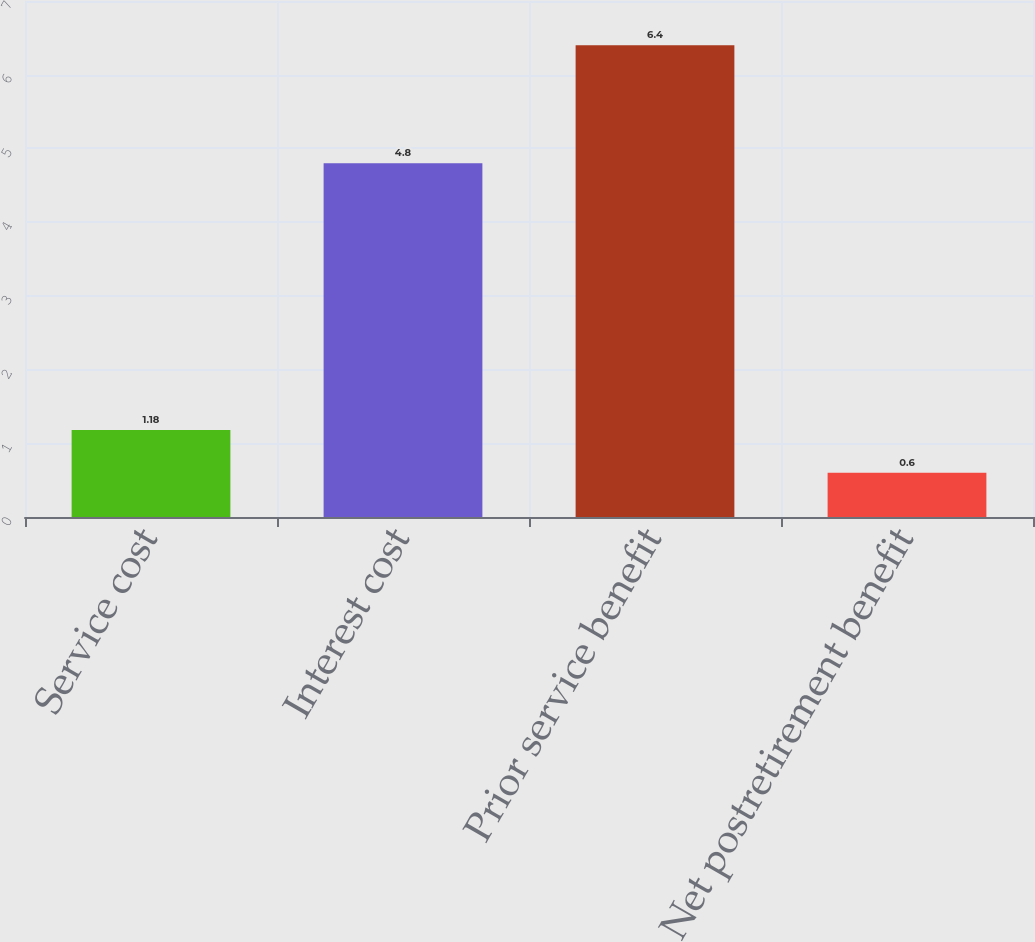Convert chart. <chart><loc_0><loc_0><loc_500><loc_500><bar_chart><fcel>Service cost<fcel>Interest cost<fcel>Prior service benefit<fcel>Net postretirement benefit<nl><fcel>1.18<fcel>4.8<fcel>6.4<fcel>0.6<nl></chart> 